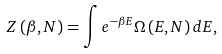<formula> <loc_0><loc_0><loc_500><loc_500>Z \left ( \beta , N \right ) = \int e ^ { - \beta E } \Omega \left ( E , N \right ) d E ,</formula> 